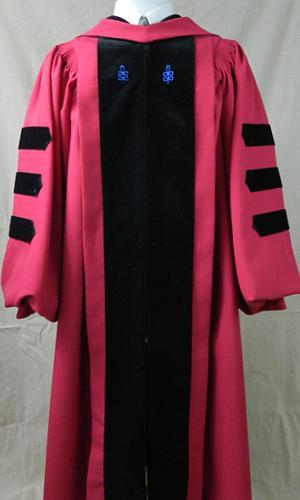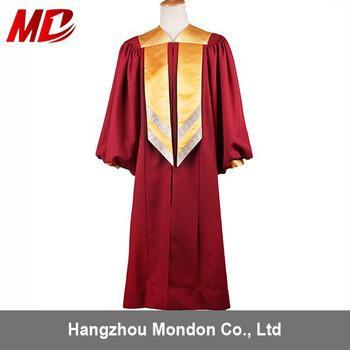The first image is the image on the left, the second image is the image on the right. Given the left and right images, does the statement "There are two pink gowns with three horizontal black stripes on the sleeve." hold true? Answer yes or no. No. The first image is the image on the left, the second image is the image on the right. For the images shown, is this caption "One image shows a human male with facial hair modeling a tasseled cap and a robe with three stripes per sleeve." true? Answer yes or no. No. 